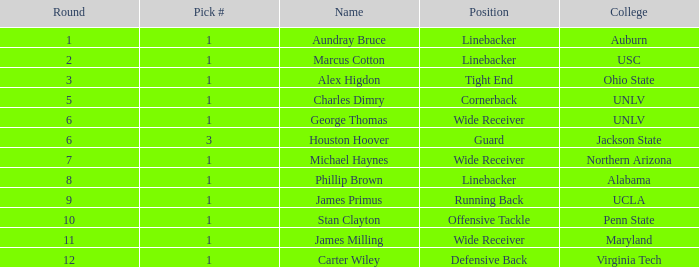What is Aundray Bruce's Pick #? 1.0. 